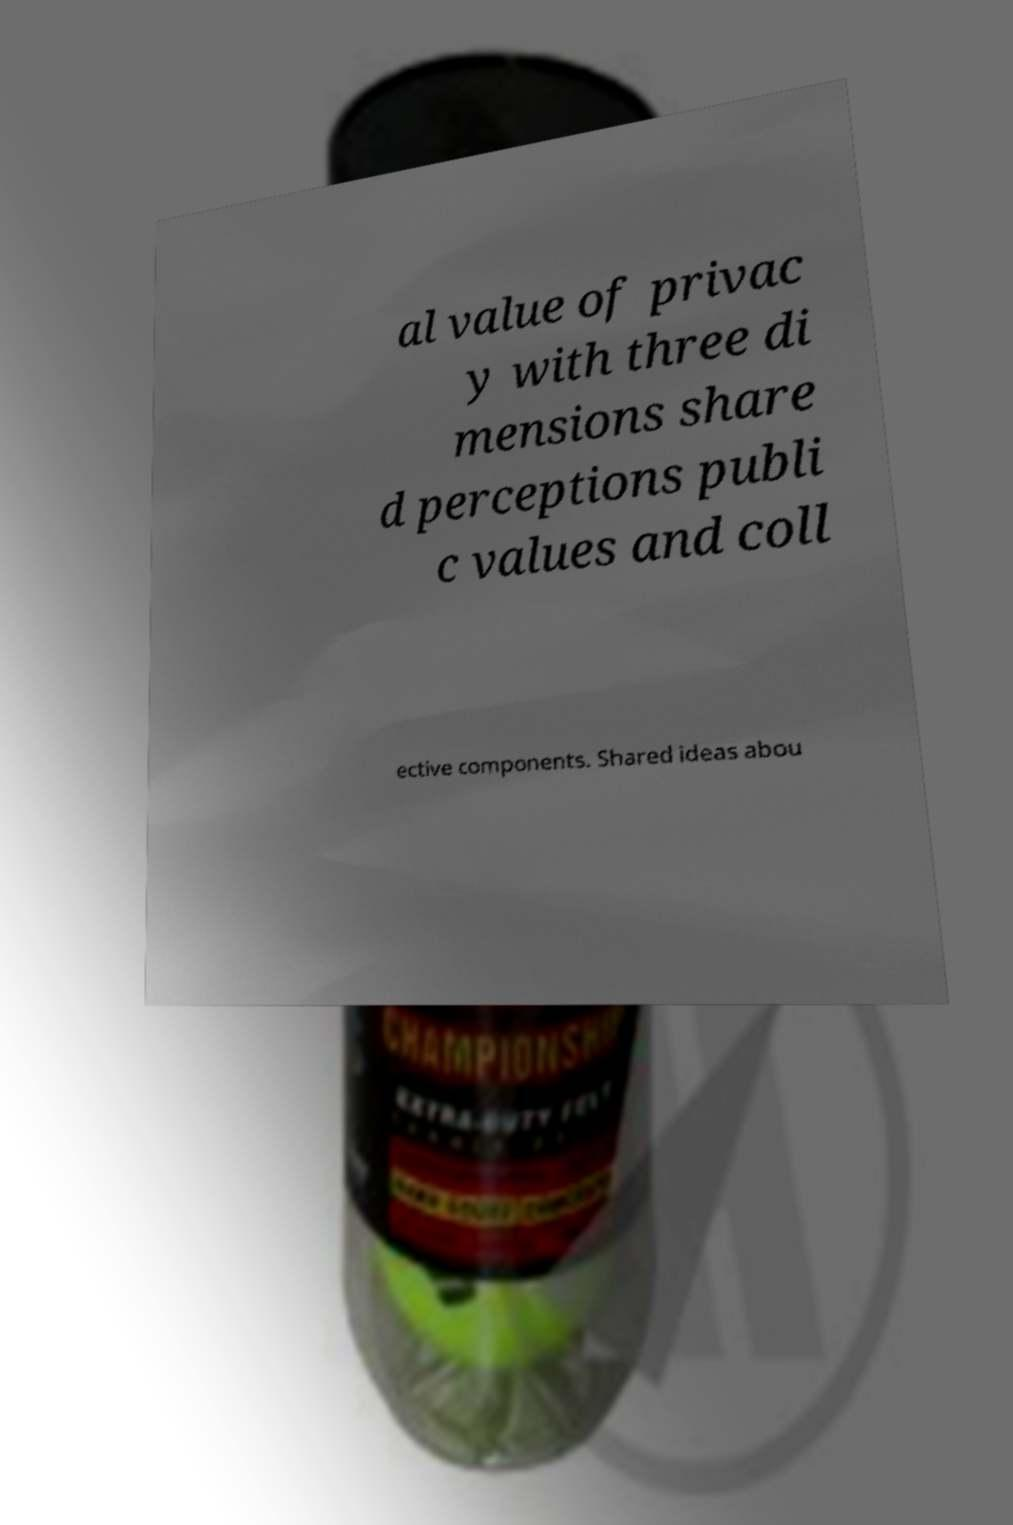What messages or text are displayed in this image? I need them in a readable, typed format. al value of privac y with three di mensions share d perceptions publi c values and coll ective components. Shared ideas abou 